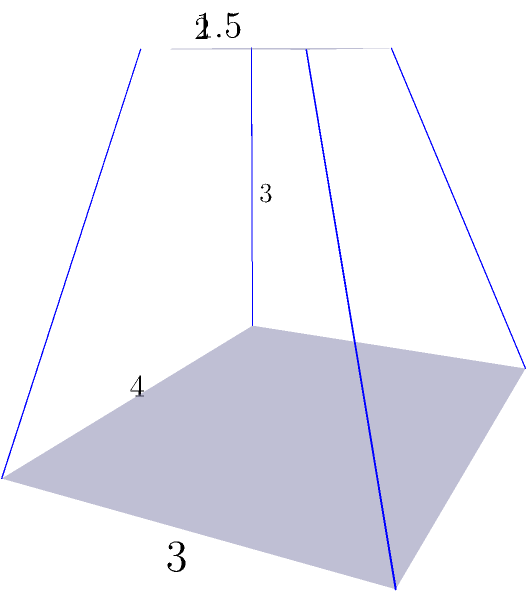As an anthropologist studying ancient Mesoamerican architecture, you encounter a truncated pyramid structure. The base of the pyramid measures 4 units by 3 units, the top measures 2 units by 1.5 units, and the height is 3 units. Calculate the volume of this truncated pyramid. To calculate the volume of a truncated pyramid, we can use the formula:

$$V = \frac{h}{3}(A_1 + A_2 + \sqrt{A_1A_2})$$

Where:
$V$ = Volume
$h$ = Height
$A_1$ = Area of the base
$A_2$ = Area of the top

Step 1: Calculate the area of the base ($A_1$)
$A_1 = 4 \times 3 = 12$ square units

Step 2: Calculate the area of the top ($A_2$)
$A_2 = 2 \times 1.5 = 3$ square units

Step 3: Calculate $\sqrt{A_1A_2}$
$\sqrt{A_1A_2} = \sqrt{12 \times 3} = \sqrt{36} = 6$ square units

Step 4: Apply the formula
$V = \frac{3}{3}(12 + 3 + 6)$
$V = 1(21)$
$V = 21$ cubic units

Therefore, the volume of the truncated pyramid is 21 cubic units.
Answer: 21 cubic units 